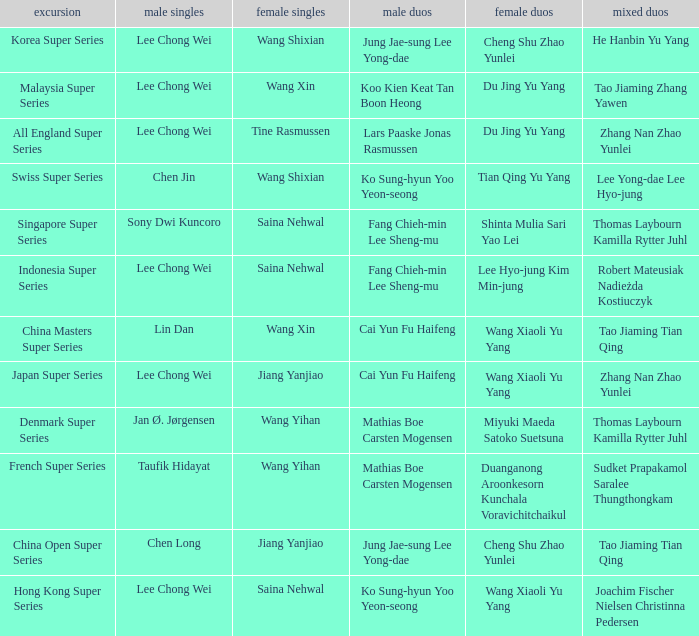Who is the womens doubles on the tour french super series? Duanganong Aroonkesorn Kunchala Voravichitchaikul. 